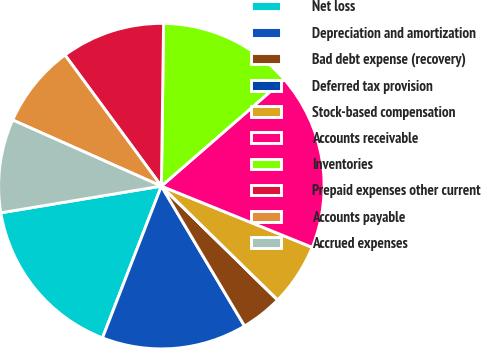Convert chart to OTSL. <chart><loc_0><loc_0><loc_500><loc_500><pie_chart><fcel>Net loss<fcel>Depreciation and amortization<fcel>Bad debt expense (recovery)<fcel>Deferred tax provision<fcel>Stock-based compensation<fcel>Accounts receivable<fcel>Inventories<fcel>Prepaid expenses other current<fcel>Accounts payable<fcel>Accrued expenses<nl><fcel>16.49%<fcel>14.43%<fcel>4.13%<fcel>0.01%<fcel>6.19%<fcel>17.52%<fcel>13.4%<fcel>10.31%<fcel>8.25%<fcel>9.28%<nl></chart> 